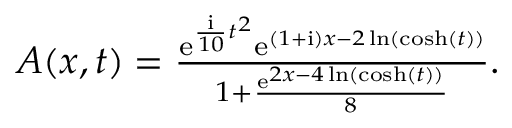<formula> <loc_0><loc_0><loc_500><loc_500>\begin{array} { r } { A ( x , t ) = \frac { e ^ { \frac { i } { 1 0 } t ^ { 2 } } e ^ { ( 1 + { i } ) x - 2 \ln ( \cosh ( t ) ) } } { 1 + \frac { e ^ { 2 x - 4 \ln ( \cosh ( t ) ) } } { 8 } } . } \end{array}</formula> 